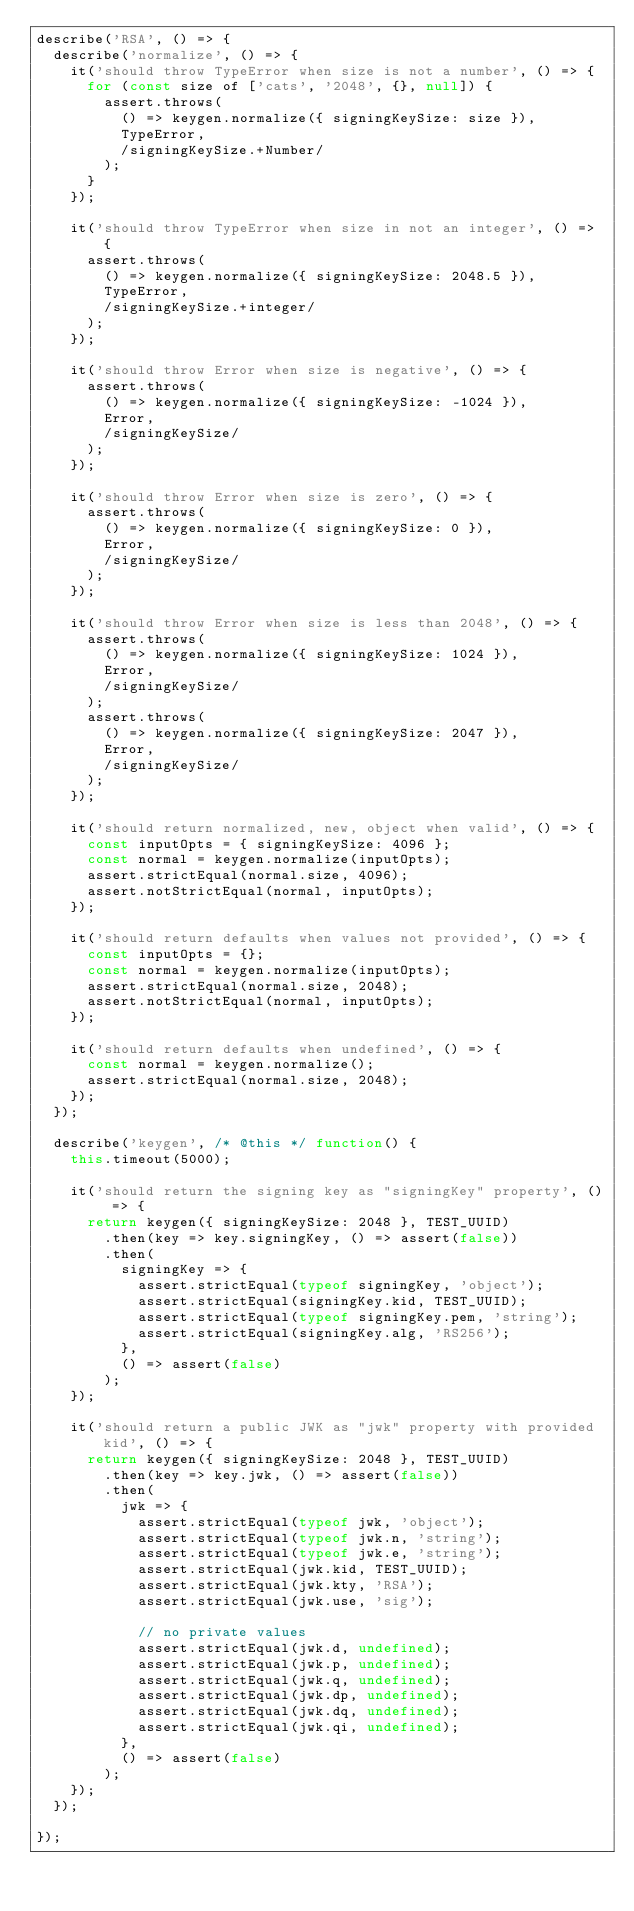Convert code to text. <code><loc_0><loc_0><loc_500><loc_500><_JavaScript_>describe('RSA', () => {
	describe('normalize', () => {
		it('should throw TypeError when size is not a number', () => {
			for (const size of ['cats', '2048', {}, null]) {
				assert.throws(
					() => keygen.normalize({ signingKeySize: size }),
					TypeError,
					/signingKeySize.+Number/
				);
			}
		});

		it('should throw TypeError when size in not an integer', () => {
			assert.throws(
				() => keygen.normalize({ signingKeySize: 2048.5 }),
				TypeError,
				/signingKeySize.+integer/
			);
		});

		it('should throw Error when size is negative', () => {
			assert.throws(
				() => keygen.normalize({ signingKeySize: -1024 }),
				Error,
				/signingKeySize/
			);
		});

		it('should throw Error when size is zero', () => {
			assert.throws(
				() => keygen.normalize({ signingKeySize: 0 }),
				Error,
				/signingKeySize/
			);
		});

		it('should throw Error when size is less than 2048', () => {
			assert.throws(
				() => keygen.normalize({ signingKeySize: 1024 }),
				Error,
				/signingKeySize/
			);
			assert.throws(
				() => keygen.normalize({ signingKeySize: 2047 }),
				Error,
				/signingKeySize/
			);
		});

		it('should return normalized, new, object when valid', () => {
			const inputOpts = { signingKeySize: 4096 };
			const normal = keygen.normalize(inputOpts);
			assert.strictEqual(normal.size, 4096);
			assert.notStrictEqual(normal, inputOpts);
		});

		it('should return defaults when values not provided', () => {
			const inputOpts = {};
			const normal = keygen.normalize(inputOpts);
			assert.strictEqual(normal.size, 2048);
			assert.notStrictEqual(normal, inputOpts);
		});

		it('should return defaults when undefined', () => {
			const normal = keygen.normalize();
			assert.strictEqual(normal.size, 2048);
		});
	});

	describe('keygen', /* @this */ function() {
		this.timeout(5000);

		it('should return the signing key as "signingKey" property', () => {
			return keygen({ signingKeySize: 2048 }, TEST_UUID)
				.then(key => key.signingKey, () => assert(false))
				.then(
					signingKey => {
						assert.strictEqual(typeof signingKey, 'object');
						assert.strictEqual(signingKey.kid, TEST_UUID);
						assert.strictEqual(typeof signingKey.pem, 'string');
						assert.strictEqual(signingKey.alg, 'RS256');
					},
					() => assert(false)
				);
		});

		it('should return a public JWK as "jwk" property with provided kid', () => {
			return keygen({ signingKeySize: 2048 }, TEST_UUID)
				.then(key => key.jwk, () => assert(false))
				.then(
					jwk => {
						assert.strictEqual(typeof jwk, 'object');
						assert.strictEqual(typeof jwk.n, 'string');
						assert.strictEqual(typeof jwk.e, 'string');
						assert.strictEqual(jwk.kid, TEST_UUID);
						assert.strictEqual(jwk.kty, 'RSA');
						assert.strictEqual(jwk.use, 'sig');

						// no private values
						assert.strictEqual(jwk.d, undefined);
						assert.strictEqual(jwk.p, undefined);
						assert.strictEqual(jwk.q, undefined);
						assert.strictEqual(jwk.dp, undefined);
						assert.strictEqual(jwk.dq, undefined);
						assert.strictEqual(jwk.qi, undefined);
					},
					() => assert(false)
				);
		});
	});

});
</code> 